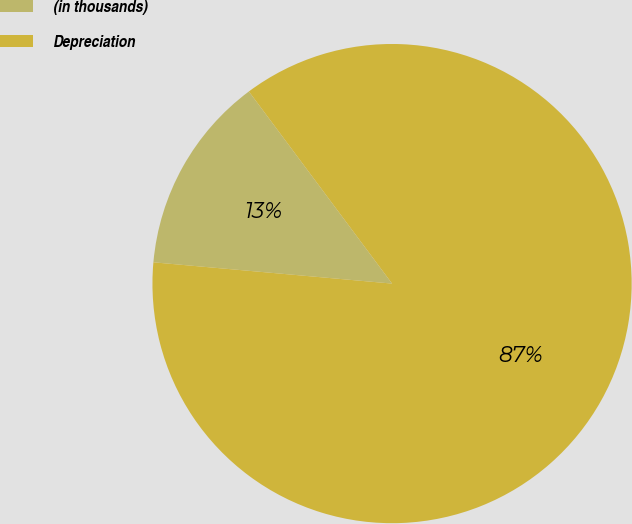Convert chart to OTSL. <chart><loc_0><loc_0><loc_500><loc_500><pie_chart><fcel>(in thousands)<fcel>Depreciation<nl><fcel>13.39%<fcel>86.61%<nl></chart> 